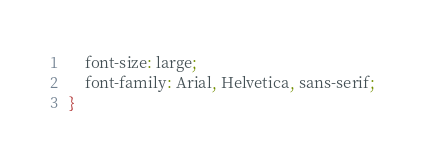<code> <loc_0><loc_0><loc_500><loc_500><_CSS_>    font-size: large;
    font-family: Arial, Helvetica, sans-serif;
}</code> 